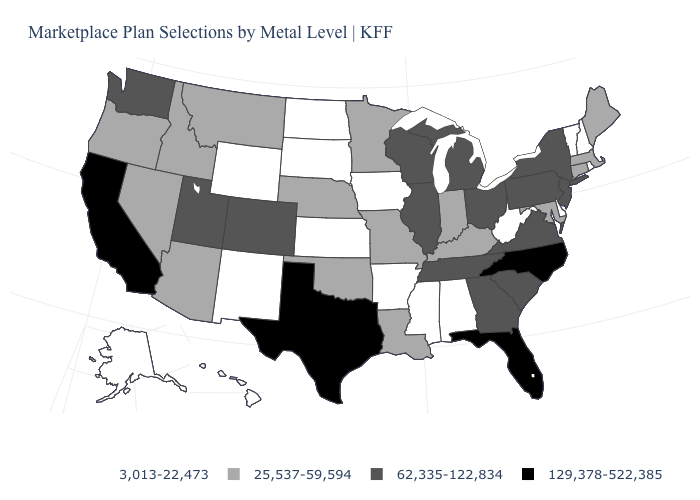What is the value of Maryland?
Quick response, please. 25,537-59,594. What is the value of Virginia?
Concise answer only. 62,335-122,834. Name the states that have a value in the range 3,013-22,473?
Give a very brief answer. Alabama, Alaska, Arkansas, Delaware, Hawaii, Iowa, Kansas, Mississippi, New Hampshire, New Mexico, North Dakota, Rhode Island, South Dakota, Vermont, West Virginia, Wyoming. Does North Carolina have a higher value than Florida?
Keep it brief. No. What is the lowest value in the USA?
Give a very brief answer. 3,013-22,473. Which states have the highest value in the USA?
Give a very brief answer. California, Florida, North Carolina, Texas. Does California have the highest value in the USA?
Keep it brief. Yes. Does Nevada have the same value as West Virginia?
Give a very brief answer. No. Name the states that have a value in the range 62,335-122,834?
Concise answer only. Colorado, Georgia, Illinois, Michigan, New Jersey, New York, Ohio, Pennsylvania, South Carolina, Tennessee, Utah, Virginia, Washington, Wisconsin. What is the value of Ohio?
Quick response, please. 62,335-122,834. Which states have the lowest value in the South?
Concise answer only. Alabama, Arkansas, Delaware, Mississippi, West Virginia. Among the states that border Oklahoma , which have the highest value?
Short answer required. Texas. What is the lowest value in states that border Wyoming?
Quick response, please. 3,013-22,473. Name the states that have a value in the range 25,537-59,594?
Keep it brief. Arizona, Connecticut, Idaho, Indiana, Kentucky, Louisiana, Maine, Maryland, Massachusetts, Minnesota, Missouri, Montana, Nebraska, Nevada, Oklahoma, Oregon. What is the highest value in states that border New York?
Be succinct. 62,335-122,834. 